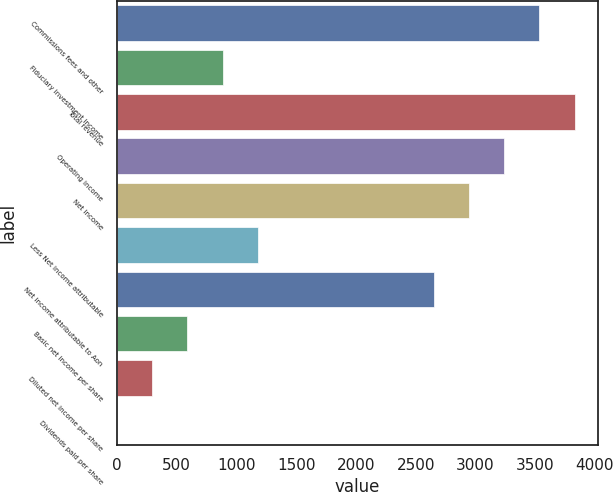<chart> <loc_0><loc_0><loc_500><loc_500><bar_chart><fcel>Commissions fees and other<fcel>Fiduciary investment income<fcel>Total revenue<fcel>Operating income<fcel>Net income<fcel>Less Net income attributable<fcel>Net income attributable to Aon<fcel>Basic net income per share<fcel>Diluted net income per share<fcel>Dividends paid per share<nl><fcel>3536.34<fcel>884.22<fcel>3831.02<fcel>3241.66<fcel>2946.98<fcel>1178.9<fcel>2652.3<fcel>589.54<fcel>294.86<fcel>0.18<nl></chart> 